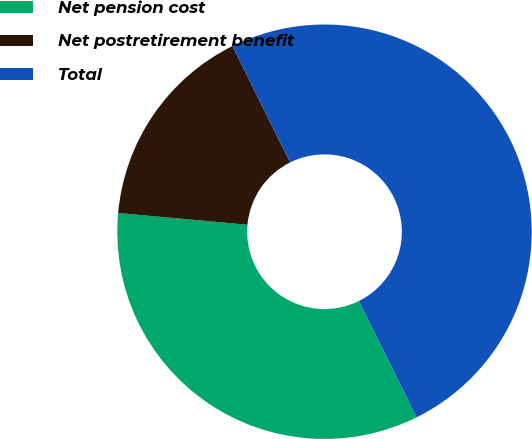<chart> <loc_0><loc_0><loc_500><loc_500><pie_chart><fcel>Net pension cost<fcel>Net postretirement benefit<fcel>Total<nl><fcel>33.77%<fcel>16.23%<fcel>50.0%<nl></chart> 